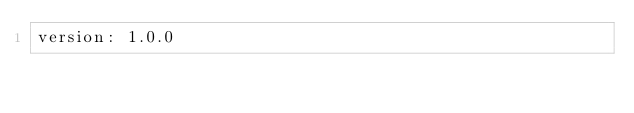<code> <loc_0><loc_0><loc_500><loc_500><_YAML_>version: 1.0.0</code> 